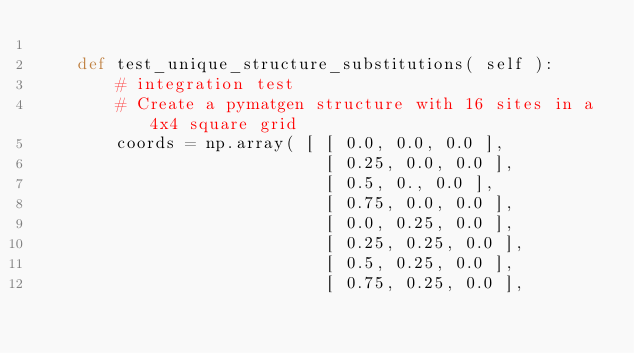Convert code to text. <code><loc_0><loc_0><loc_500><loc_500><_Python_> 
    def test_unique_structure_substitutions( self ):
        # integration test
        # Create a pymatgen structure with 16 sites in a 4x4 square grid
        coords = np.array( [ [ 0.0, 0.0, 0.0 ],
                             [ 0.25, 0.0, 0.0 ],
                             [ 0.5, 0., 0.0 ],
                             [ 0.75, 0.0, 0.0 ],
                             [ 0.0, 0.25, 0.0 ],
                             [ 0.25, 0.25, 0.0 ],
                             [ 0.5, 0.25, 0.0 ],
                             [ 0.75, 0.25, 0.0 ],</code> 